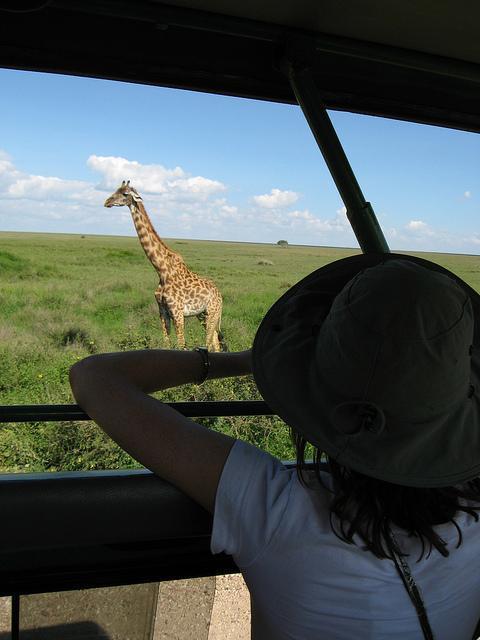How many giraffes can you see?
Give a very brief answer. 1. 